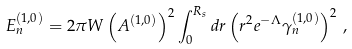Convert formula to latex. <formula><loc_0><loc_0><loc_500><loc_500>E ^ { ( 1 , 0 ) } _ { n } = 2 \pi W \left ( A ^ { ( 1 , 0 ) } \right ) ^ { 2 } \int _ { 0 } ^ { R _ { s } } d r \left ( r ^ { 2 } e ^ { - \Lambda } \gamma ^ { ( 1 , 0 ) } _ { n } \right ) ^ { 2 } \, ,</formula> 